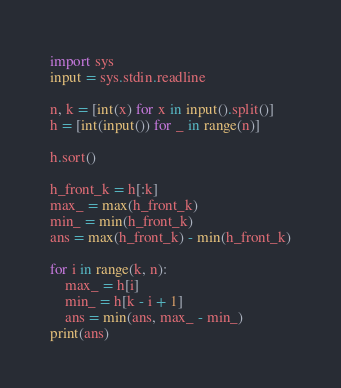Convert code to text. <code><loc_0><loc_0><loc_500><loc_500><_Python_>import sys
input = sys.stdin.readline

n, k = [int(x) for x in input().split()]
h = [int(input()) for _ in range(n)]

h.sort()

h_front_k = h[:k]
max_ = max(h_front_k)
min_ = min(h_front_k)
ans = max(h_front_k) - min(h_front_k)

for i in range(k, n):
    max_ = h[i]
    min_ = h[k - i + 1]
    ans = min(ans, max_ - min_)
print(ans)
</code> 